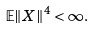Convert formula to latex. <formula><loc_0><loc_0><loc_500><loc_500>\mathbb { E } \| X \| ^ { 4 } < \infty .</formula> 